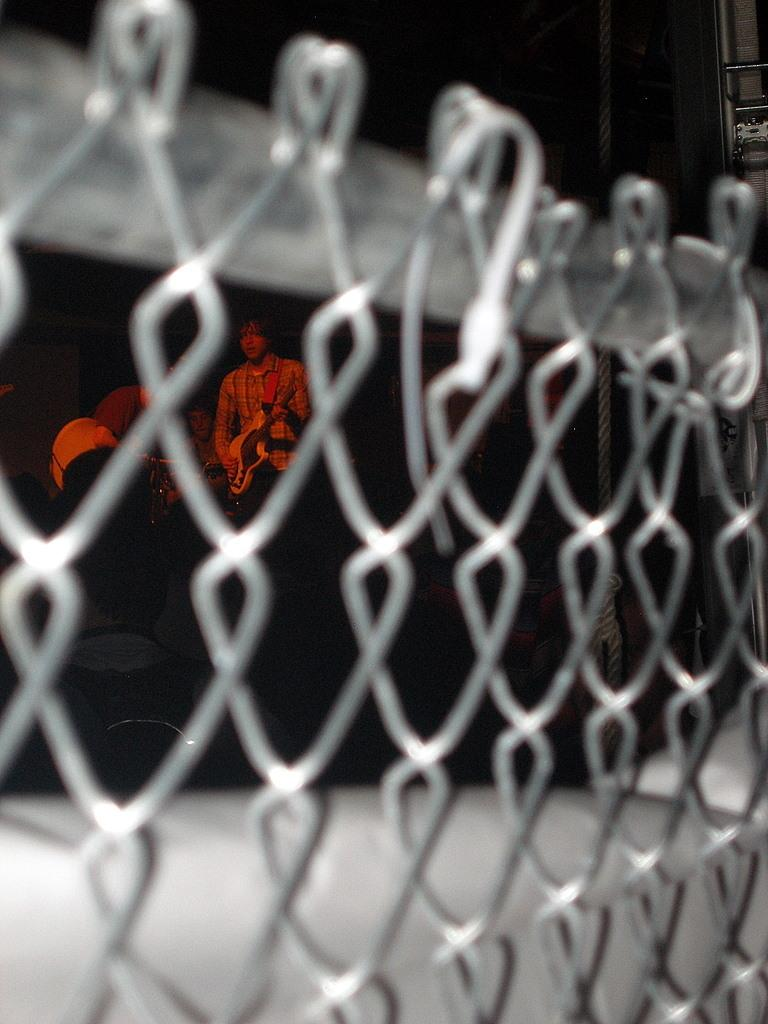What is present in the image that separates spaces or provides a barrier? There is a fence in the image. What can be seen beyond the fence? People are visible through the fence. How would you describe the background of the image? The background of the image is blurred. What type of bit is being used by the person on the other side of the fence? There is no bit visible in the image, as it is not related to the fence or the people visible through it. 